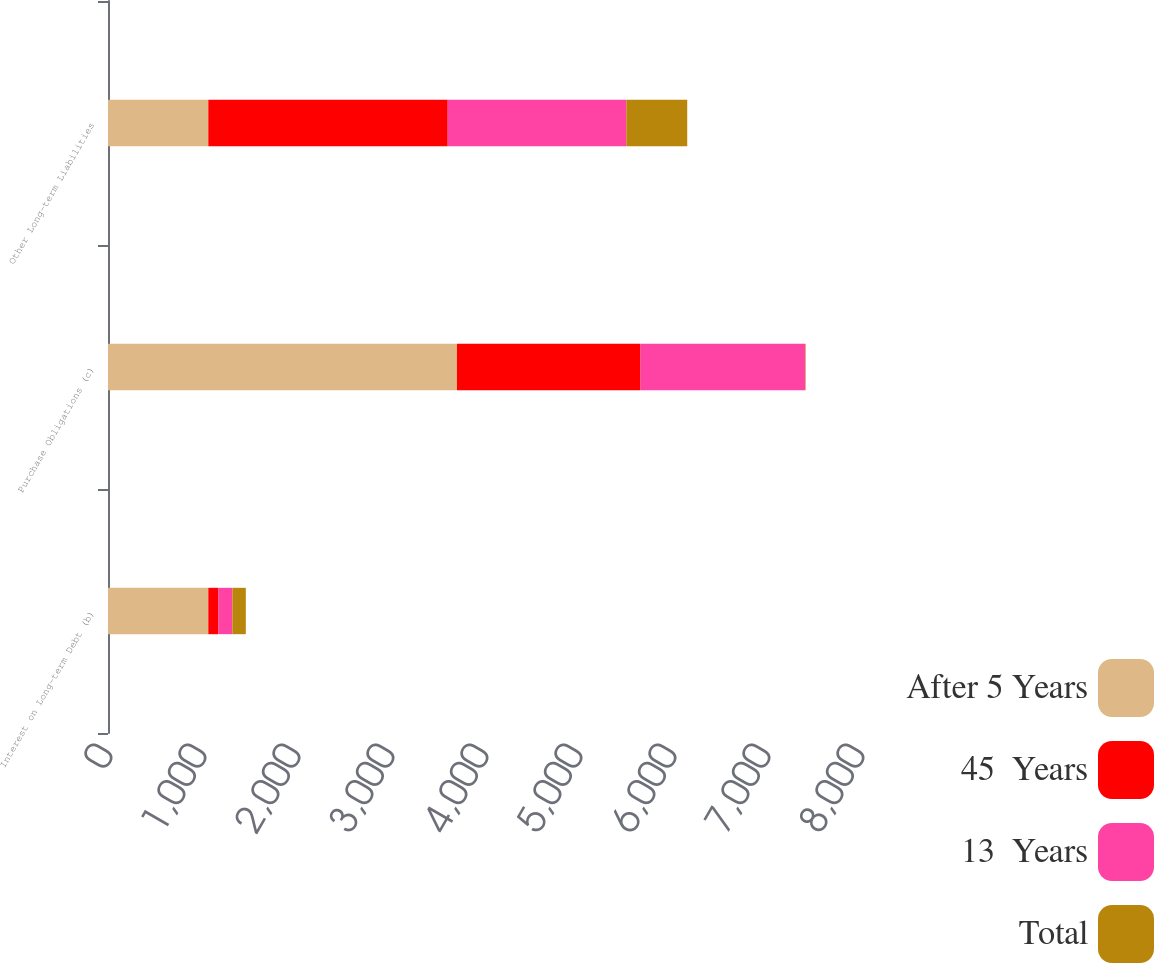<chart> <loc_0><loc_0><loc_500><loc_500><stacked_bar_chart><ecel><fcel>Interest on Long-term Debt (b)<fcel>Purchase Obligations (c)<fcel>Other Long-term Liabilities<nl><fcel>After 5 Years<fcel>1067<fcel>3712<fcel>1067<nl><fcel>45  Years<fcel>108<fcel>1953<fcel>2547<nl><fcel>13  Years<fcel>148<fcel>1752<fcel>1900<nl><fcel>Total<fcel>143<fcel>5<fcel>648<nl></chart> 